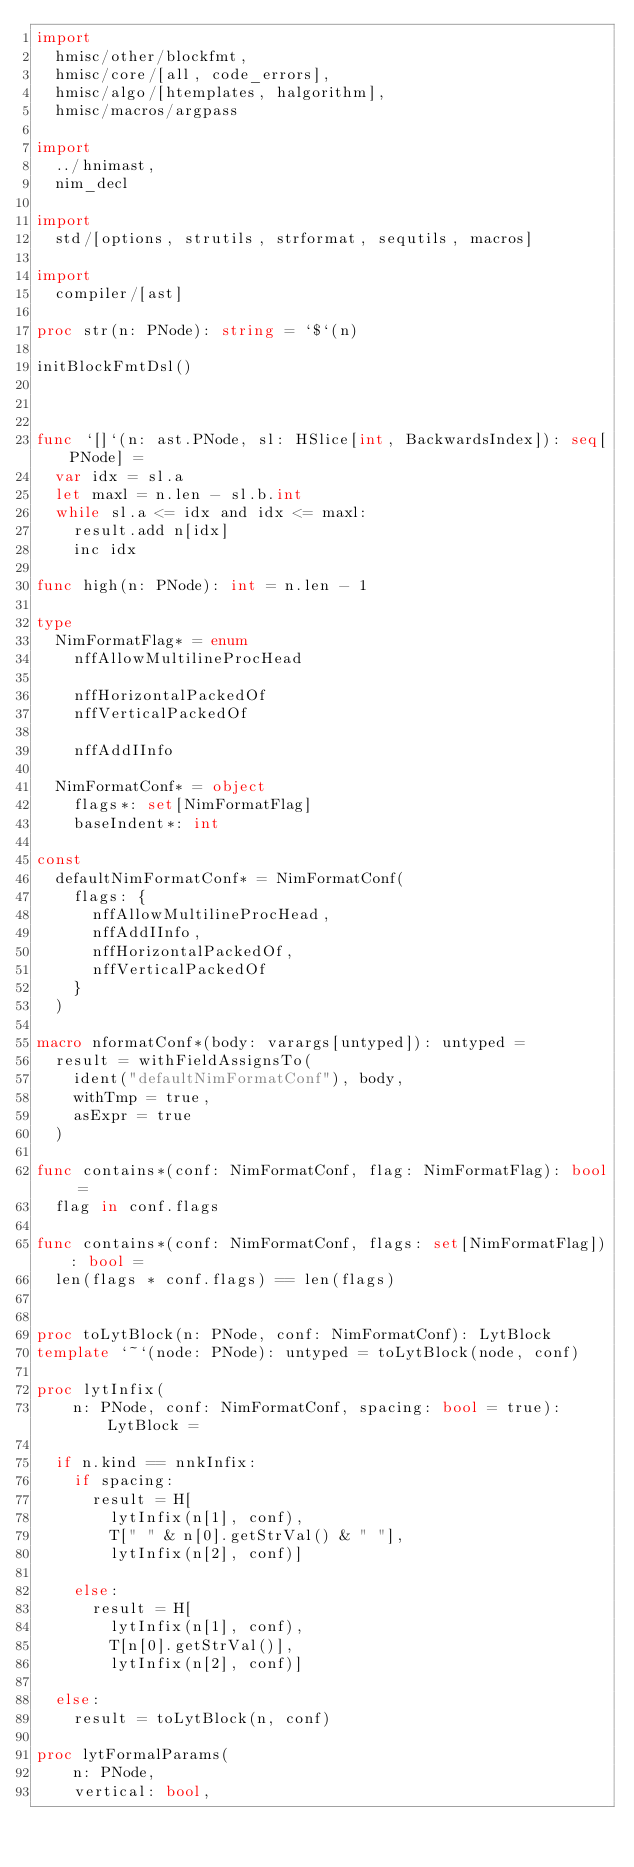Convert code to text. <code><loc_0><loc_0><loc_500><loc_500><_Nim_>import
  hmisc/other/blockfmt,
  hmisc/core/[all, code_errors],
  hmisc/algo/[htemplates, halgorithm],
  hmisc/macros/argpass

import
  ../hnimast,
  nim_decl

import
  std/[options, strutils, strformat, sequtils, macros]

import
  compiler/[ast]

proc str(n: PNode): string = `$`(n)

initBlockFmtDsl()



func `[]`(n: ast.PNode, sl: HSlice[int, BackwardsIndex]): seq[PNode] =
  var idx = sl.a
  let maxl = n.len - sl.b.int
  while sl.a <= idx and idx <= maxl:
    result.add n[idx]
    inc idx

func high(n: PNode): int = n.len - 1

type
  NimFormatFlag* = enum
    nffAllowMultilineProcHead

    nffHorizontalPackedOf
    nffVerticalPackedOf

    nffAddIInfo

  NimFormatConf* = object
    flags*: set[NimFormatFlag]
    baseIndent*: int

const
  defaultNimFormatConf* = NimFormatConf(
    flags: {
      nffAllowMultilineProcHead,
      nffAddIInfo,
      nffHorizontalPackedOf,
      nffVerticalPackedOf
    }
  )

macro nformatConf*(body: varargs[untyped]): untyped =
  result = withFieldAssignsTo(
    ident("defaultNimFormatConf"), body,
    withTmp = true,
    asExpr = true
  )

func contains*(conf: NimFormatConf, flag: NimFormatFlag): bool =
  flag in conf.flags

func contains*(conf: NimFormatConf, flags: set[NimFormatFlag]): bool =
  len(flags * conf.flags) == len(flags)


proc toLytBlock(n: PNode, conf: NimFormatConf): LytBlock
template `~`(node: PNode): untyped = toLytBlock(node, conf)

proc lytInfix(
    n: PNode, conf: NimFormatConf, spacing: bool = true): LytBlock =

  if n.kind == nnkInfix:
    if spacing:
      result = H[
        lytInfix(n[1], conf),
        T[" " & n[0].getStrVal() & " "],
        lytInfix(n[2], conf)]

    else:
      result = H[
        lytInfix(n[1], conf),
        T[n[0].getStrVal()],
        lytInfix(n[2], conf)]

  else:
    result = toLytBlock(n, conf)

proc lytFormalParams(
    n: PNode,
    vertical: bool,</code> 